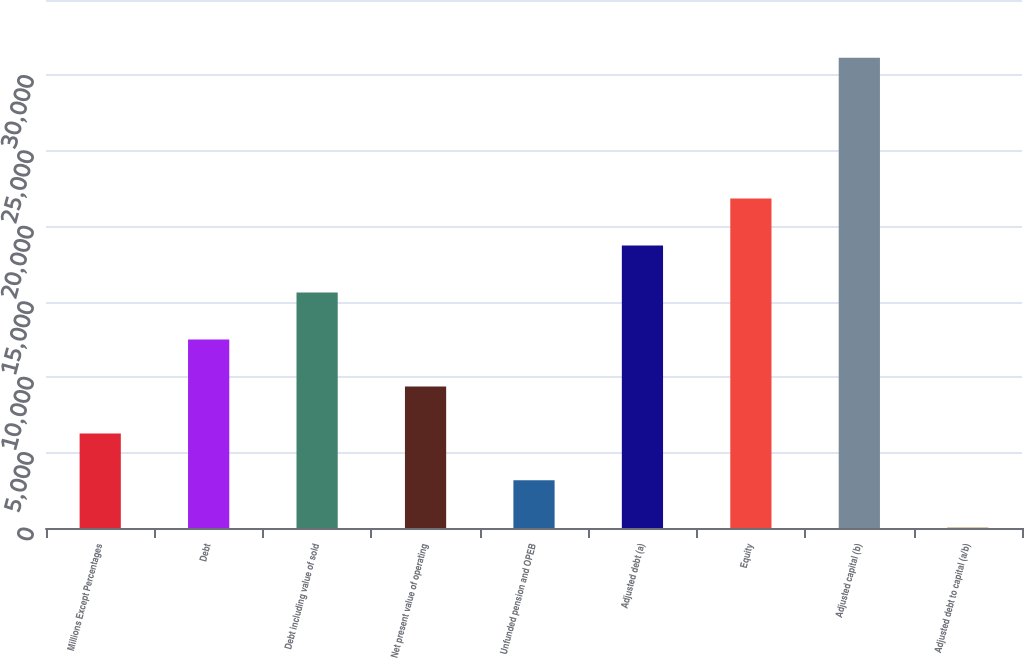<chart> <loc_0><loc_0><loc_500><loc_500><bar_chart><fcel>Millions Except Percentages<fcel>Debt<fcel>Debt including value of sold<fcel>Net present value of operating<fcel>Unfunded pension and OPEB<fcel>Adjusted debt (a)<fcel>Equity<fcel>Adjusted capital (b)<fcel>Adjusted debt to capital (a/b)<nl><fcel>6272.28<fcel>12498.5<fcel>15611.5<fcel>9385.37<fcel>3159.19<fcel>18724.6<fcel>21837.7<fcel>31177<fcel>46.1<nl></chart> 